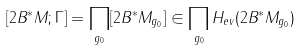<formula> <loc_0><loc_0><loc_500><loc_500>[ 2 B ^ { * } M ; \Gamma ] = \prod _ { g _ { 0 } } [ 2 B ^ { * } M _ { g _ { 0 } } ] \in \prod _ { g _ { 0 } } H _ { e v } ( 2 B ^ { * } M _ { g _ { 0 } } )</formula> 